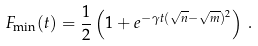Convert formula to latex. <formula><loc_0><loc_0><loc_500><loc_500>F _ { \min } ( t ) = \frac { 1 } { 2 } \left ( 1 + e ^ { - \gamma t ( \sqrt { n } - \sqrt { m } ) ^ { 2 } } \right ) \, .</formula> 